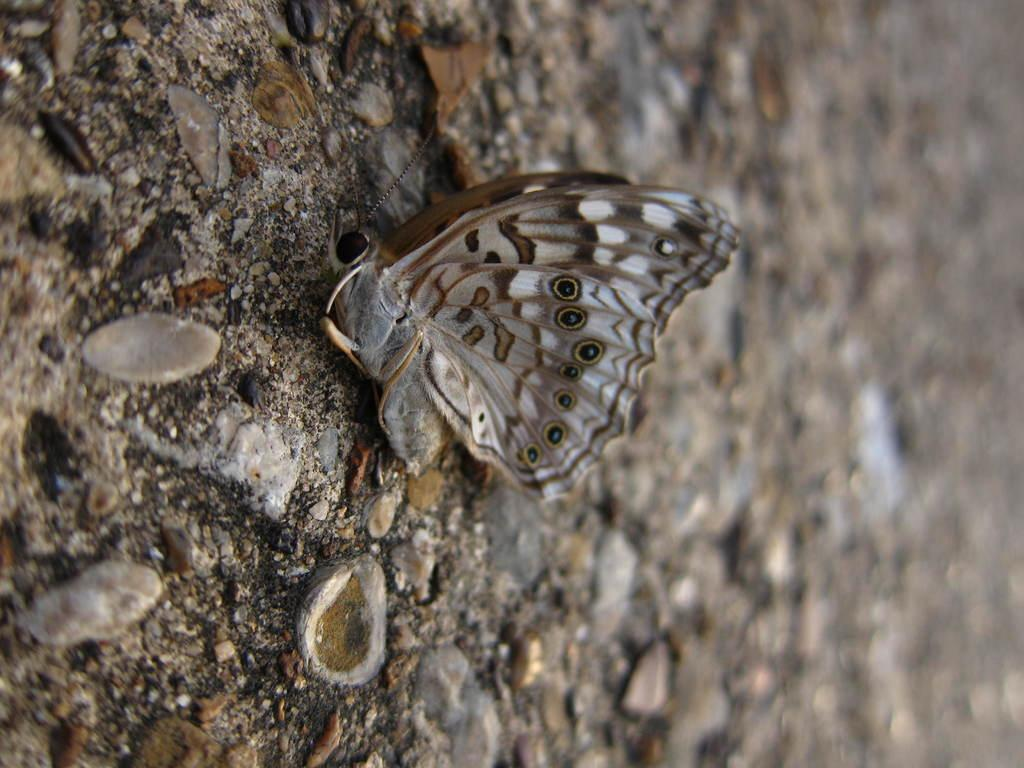What is the main subject of the image? There is a butterfly in the image. What is the butterfly resting on in the image? The butterfly is on a stone surface. What type of humor can be seen in the image? There is no humor present in the image; it features a butterfly on a stone surface. 